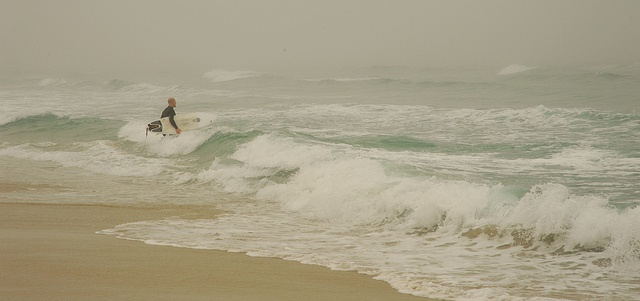Describe the objects in this image and their specific colors. I can see surfboard in darkgray, tan, and gray tones and people in darkgray, black, gray, and tan tones in this image. 